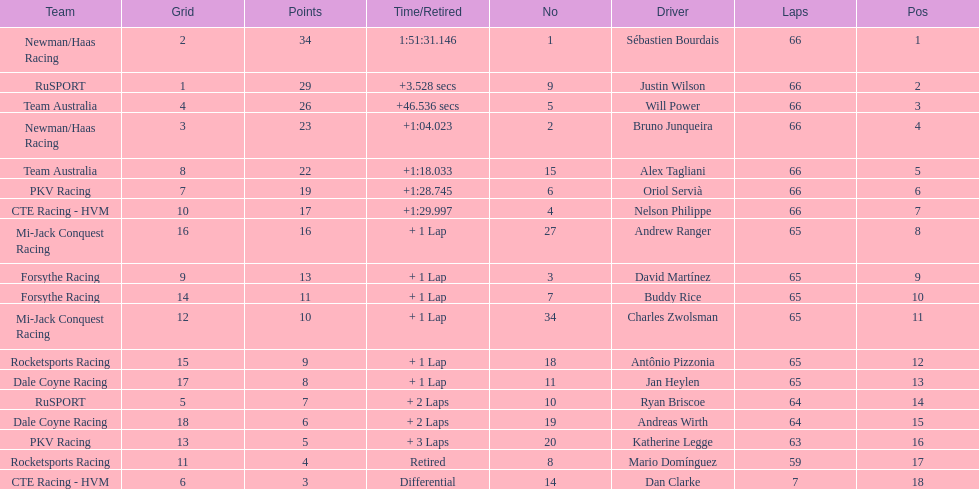Rice finished 10th. who finished next? Charles Zwolsman. 